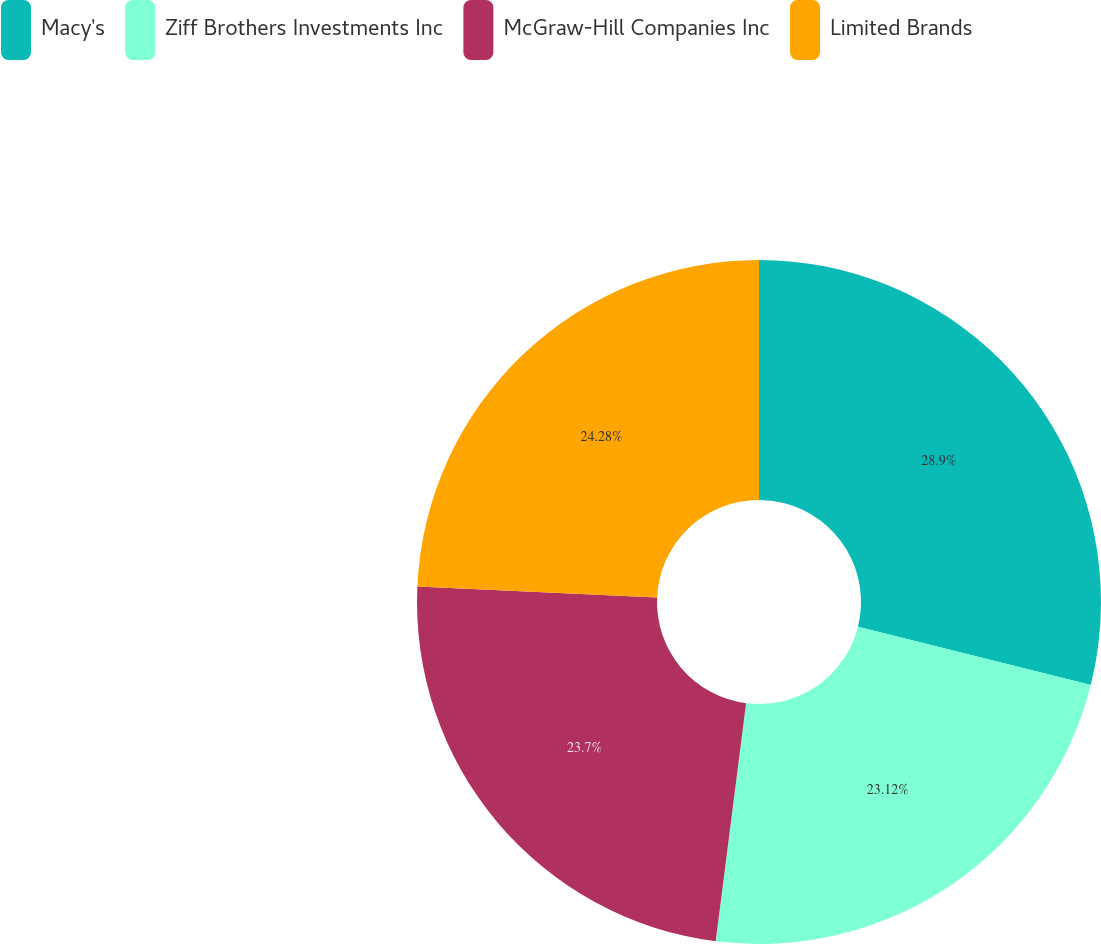Convert chart. <chart><loc_0><loc_0><loc_500><loc_500><pie_chart><fcel>Macy's<fcel>Ziff Brothers Investments Inc<fcel>McGraw-Hill Companies Inc<fcel>Limited Brands<nl><fcel>28.9%<fcel>23.12%<fcel>23.7%<fcel>24.28%<nl></chart> 